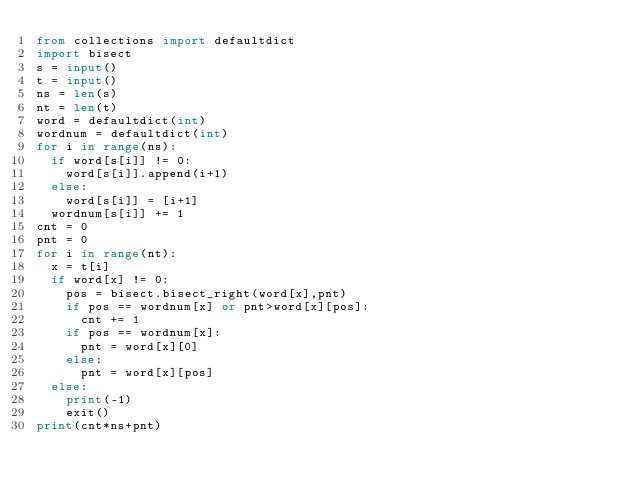Convert code to text. <code><loc_0><loc_0><loc_500><loc_500><_Python_>from collections import defaultdict
import bisect
s = input()
t = input()
ns = len(s)
nt = len(t)
word = defaultdict(int)
wordnum = defaultdict(int)
for i in range(ns):
  if word[s[i]] != 0:
    word[s[i]].append(i+1)
  else:
    word[s[i]] = [i+1]
  wordnum[s[i]] += 1
cnt = 0
pnt = 0
for i in range(nt):
  x = t[i]
  if word[x] != 0:
    pos = bisect.bisect_right(word[x],pnt)
    if pos == wordnum[x] or pnt>word[x][pos]:
      cnt += 1
    if pos == wordnum[x]:
      pnt = word[x][0]
    else:
      pnt = word[x][pos]
  else:
    print(-1)
    exit()
print(cnt*ns+pnt)</code> 